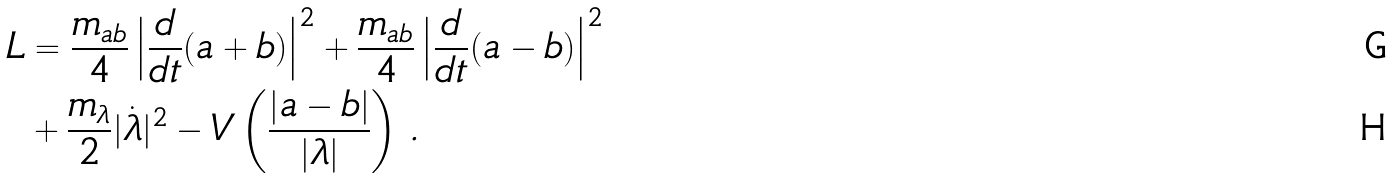<formula> <loc_0><loc_0><loc_500><loc_500>L & = \frac { m _ { a b } } { 4 } \left | \frac { d } { d t } ( a + b ) \right | ^ { 2 } + \frac { m _ { a b } } { 4 } \left | \frac { d } { d t } ( a - b ) \right | ^ { 2 } \\ & + \frac { m _ { \lambda } } { 2 } | \dot { \lambda } | ^ { 2 } - V \left ( \frac { | a - b | } { | \lambda | } \right ) \, .</formula> 